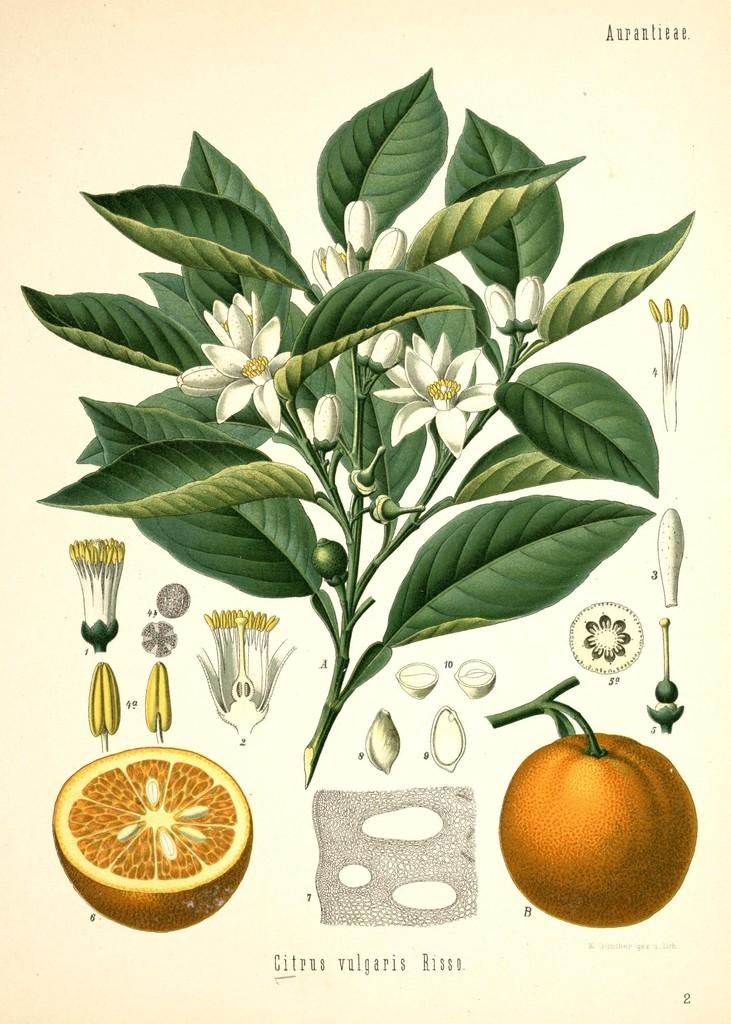What type of plant life is present in the image? There are leaves and flowers in the image. What type of fruit is visible in the image? There is an orange fruit in the image. Can you describe the condition of the orange fruit? A piece of an orange is visible on the left side of the image. What part of a flower can be seen on the left side of the image? Parts of a flower are visible on the left side of the image. What is located at the bottom of the image? There is some text at the bottom of the image. Can you tell me how many straws are present in the image? There are no straws present in the image. What type of animal can be seen in the zoo in the image? There is no zoo or animal present in the image. 